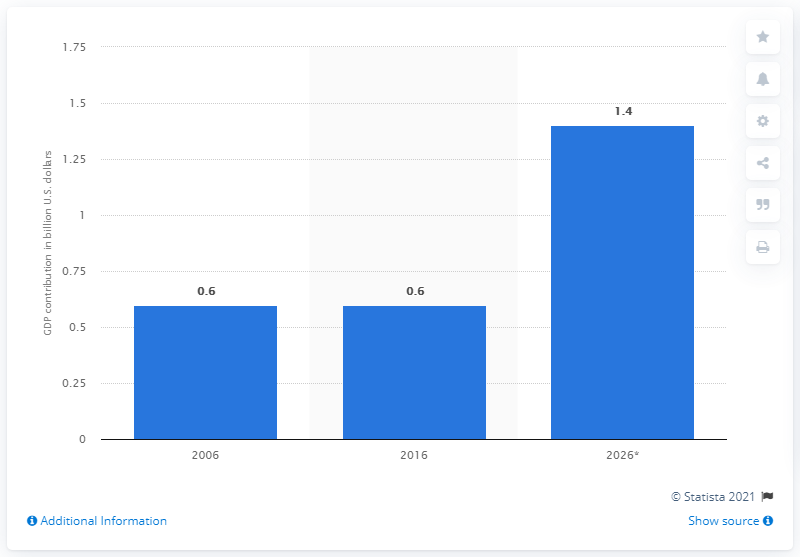Highlight a few significant elements in this photo. According to estimates, Marrakech's direct tourism contribution to the GDP of Morocco in 2026 was 1.4.. 